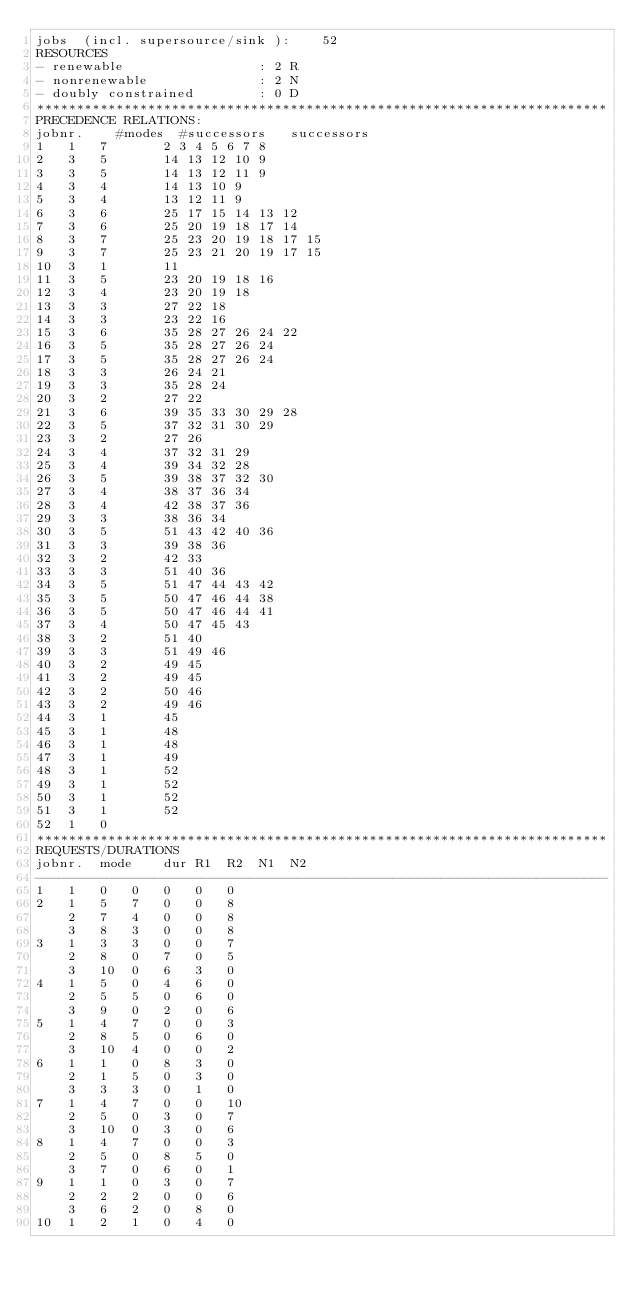Convert code to text. <code><loc_0><loc_0><loc_500><loc_500><_ObjectiveC_>jobs  (incl. supersource/sink ):	52
RESOURCES
- renewable                 : 2 R
- nonrenewable              : 2 N
- doubly constrained        : 0 D
************************************************************************
PRECEDENCE RELATIONS:
jobnr.    #modes  #successors   successors
1	1	7		2 3 4 5 6 7 8 
2	3	5		14 13 12 10 9 
3	3	5		14 13 12 11 9 
4	3	4		14 13 10 9 
5	3	4		13 12 11 9 
6	3	6		25 17 15 14 13 12 
7	3	6		25 20 19 18 17 14 
8	3	7		25 23 20 19 18 17 15 
9	3	7		25 23 21 20 19 17 15 
10	3	1		11 
11	3	5		23 20 19 18 16 
12	3	4		23 20 19 18 
13	3	3		27 22 18 
14	3	3		23 22 16 
15	3	6		35 28 27 26 24 22 
16	3	5		35 28 27 26 24 
17	3	5		35 28 27 26 24 
18	3	3		26 24 21 
19	3	3		35 28 24 
20	3	2		27 22 
21	3	6		39 35 33 30 29 28 
22	3	5		37 32 31 30 29 
23	3	2		27 26 
24	3	4		37 32 31 29 
25	3	4		39 34 32 28 
26	3	5		39 38 37 32 30 
27	3	4		38 37 36 34 
28	3	4		42 38 37 36 
29	3	3		38 36 34 
30	3	5		51 43 42 40 36 
31	3	3		39 38 36 
32	3	2		42 33 
33	3	3		51 40 36 
34	3	5		51 47 44 43 42 
35	3	5		50 47 46 44 38 
36	3	5		50 47 46 44 41 
37	3	4		50 47 45 43 
38	3	2		51 40 
39	3	3		51 49 46 
40	3	2		49 45 
41	3	2		49 45 
42	3	2		50 46 
43	3	2		49 46 
44	3	1		45 
45	3	1		48 
46	3	1		48 
47	3	1		49 
48	3	1		52 
49	3	1		52 
50	3	1		52 
51	3	1		52 
52	1	0		
************************************************************************
REQUESTS/DURATIONS
jobnr.	mode	dur	R1	R2	N1	N2	
------------------------------------------------------------------------
1	1	0	0	0	0	0	
2	1	5	7	0	0	8	
	2	7	4	0	0	8	
	3	8	3	0	0	8	
3	1	3	3	0	0	7	
	2	8	0	7	0	5	
	3	10	0	6	3	0	
4	1	5	0	4	6	0	
	2	5	5	0	6	0	
	3	9	0	2	0	6	
5	1	4	7	0	0	3	
	2	8	5	0	6	0	
	3	10	4	0	0	2	
6	1	1	0	8	3	0	
	2	1	5	0	3	0	
	3	3	3	0	1	0	
7	1	4	7	0	0	10	
	2	5	0	3	0	7	
	3	10	0	3	0	6	
8	1	4	7	0	0	3	
	2	5	0	8	5	0	
	3	7	0	6	0	1	
9	1	1	0	3	0	7	
	2	2	2	0	0	6	
	3	6	2	0	8	0	
10	1	2	1	0	4	0	</code> 